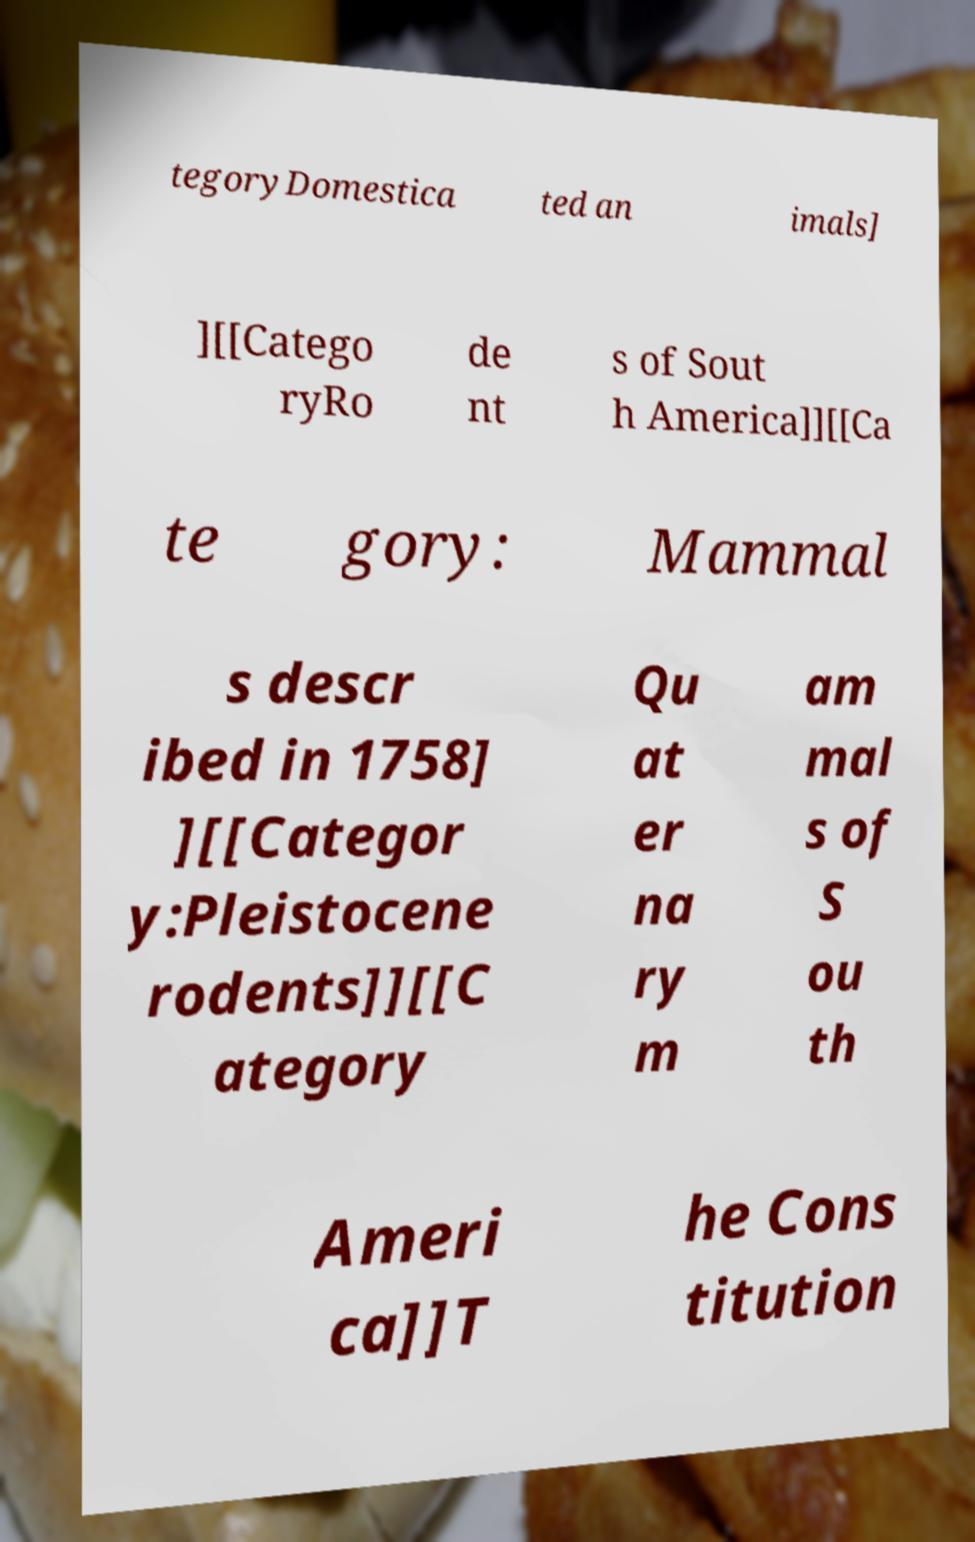Please identify and transcribe the text found in this image. tegoryDomestica ted an imals] ][[Catego ryRo de nt s of Sout h America]][[Ca te gory: Mammal s descr ibed in 1758] ][[Categor y:Pleistocene rodents]][[C ategory Qu at er na ry m am mal s of S ou th Ameri ca]]T he Cons titution 